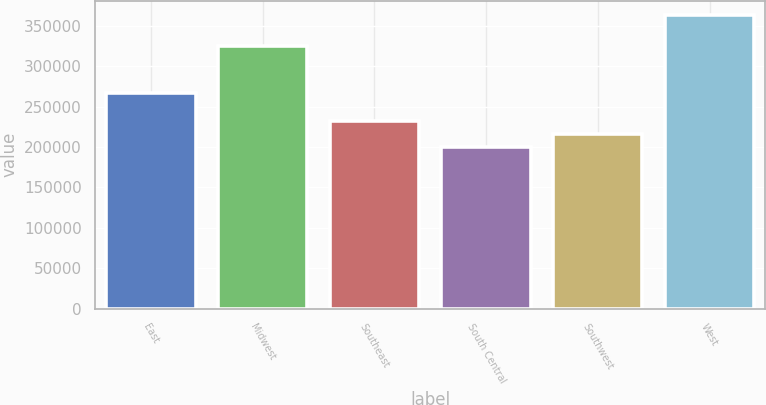Convert chart. <chart><loc_0><loc_0><loc_500><loc_500><bar_chart><fcel>East<fcel>Midwest<fcel>Southeast<fcel>South Central<fcel>Southwest<fcel>West<nl><fcel>266600<fcel>325300<fcel>232500<fcel>199900<fcel>216200<fcel>362900<nl></chart> 